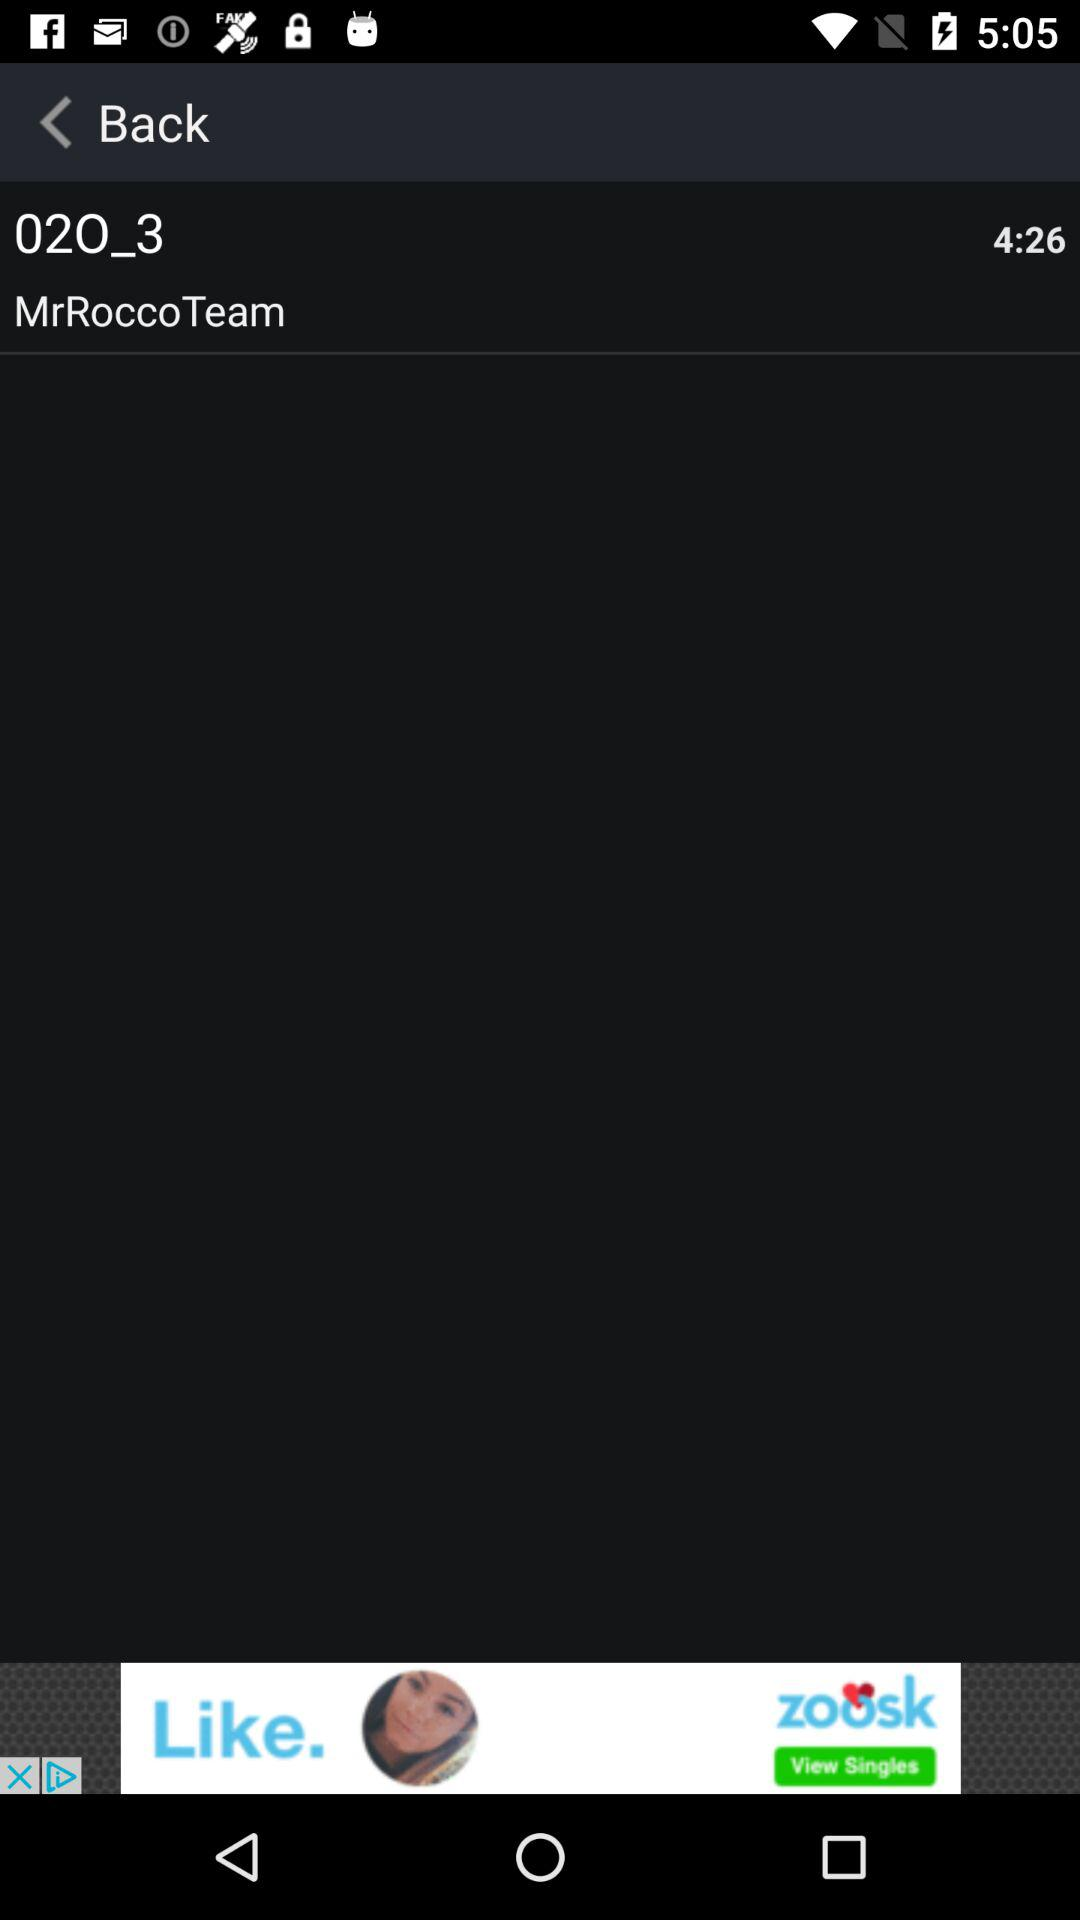How many people liked "02O_3"?
When the provided information is insufficient, respond with <no answer>. <no answer> 